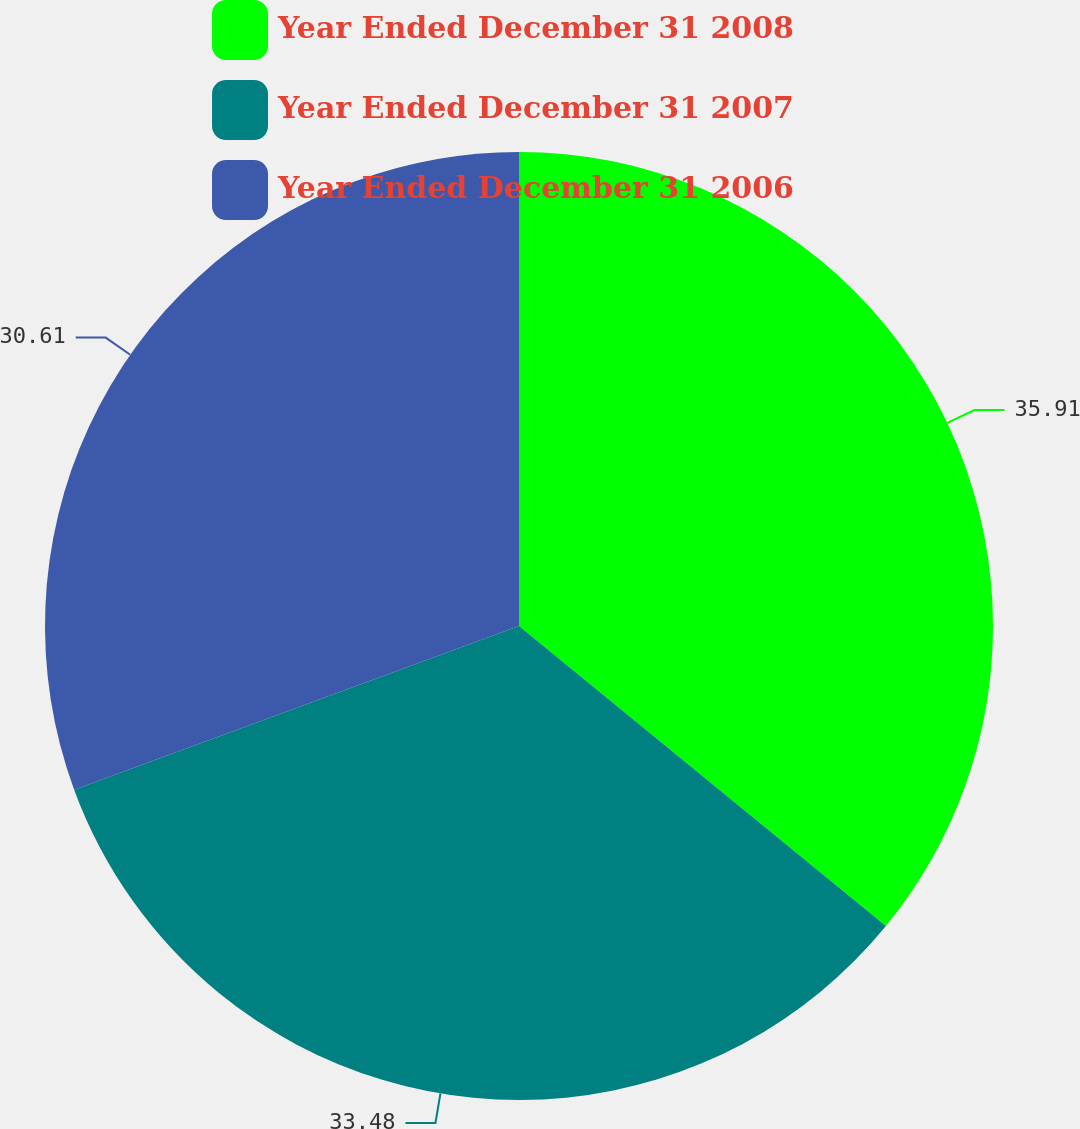<chart> <loc_0><loc_0><loc_500><loc_500><pie_chart><fcel>Year Ended December 31 2008<fcel>Year Ended December 31 2007<fcel>Year Ended December 31 2006<nl><fcel>35.91%<fcel>33.48%<fcel>30.61%<nl></chart> 